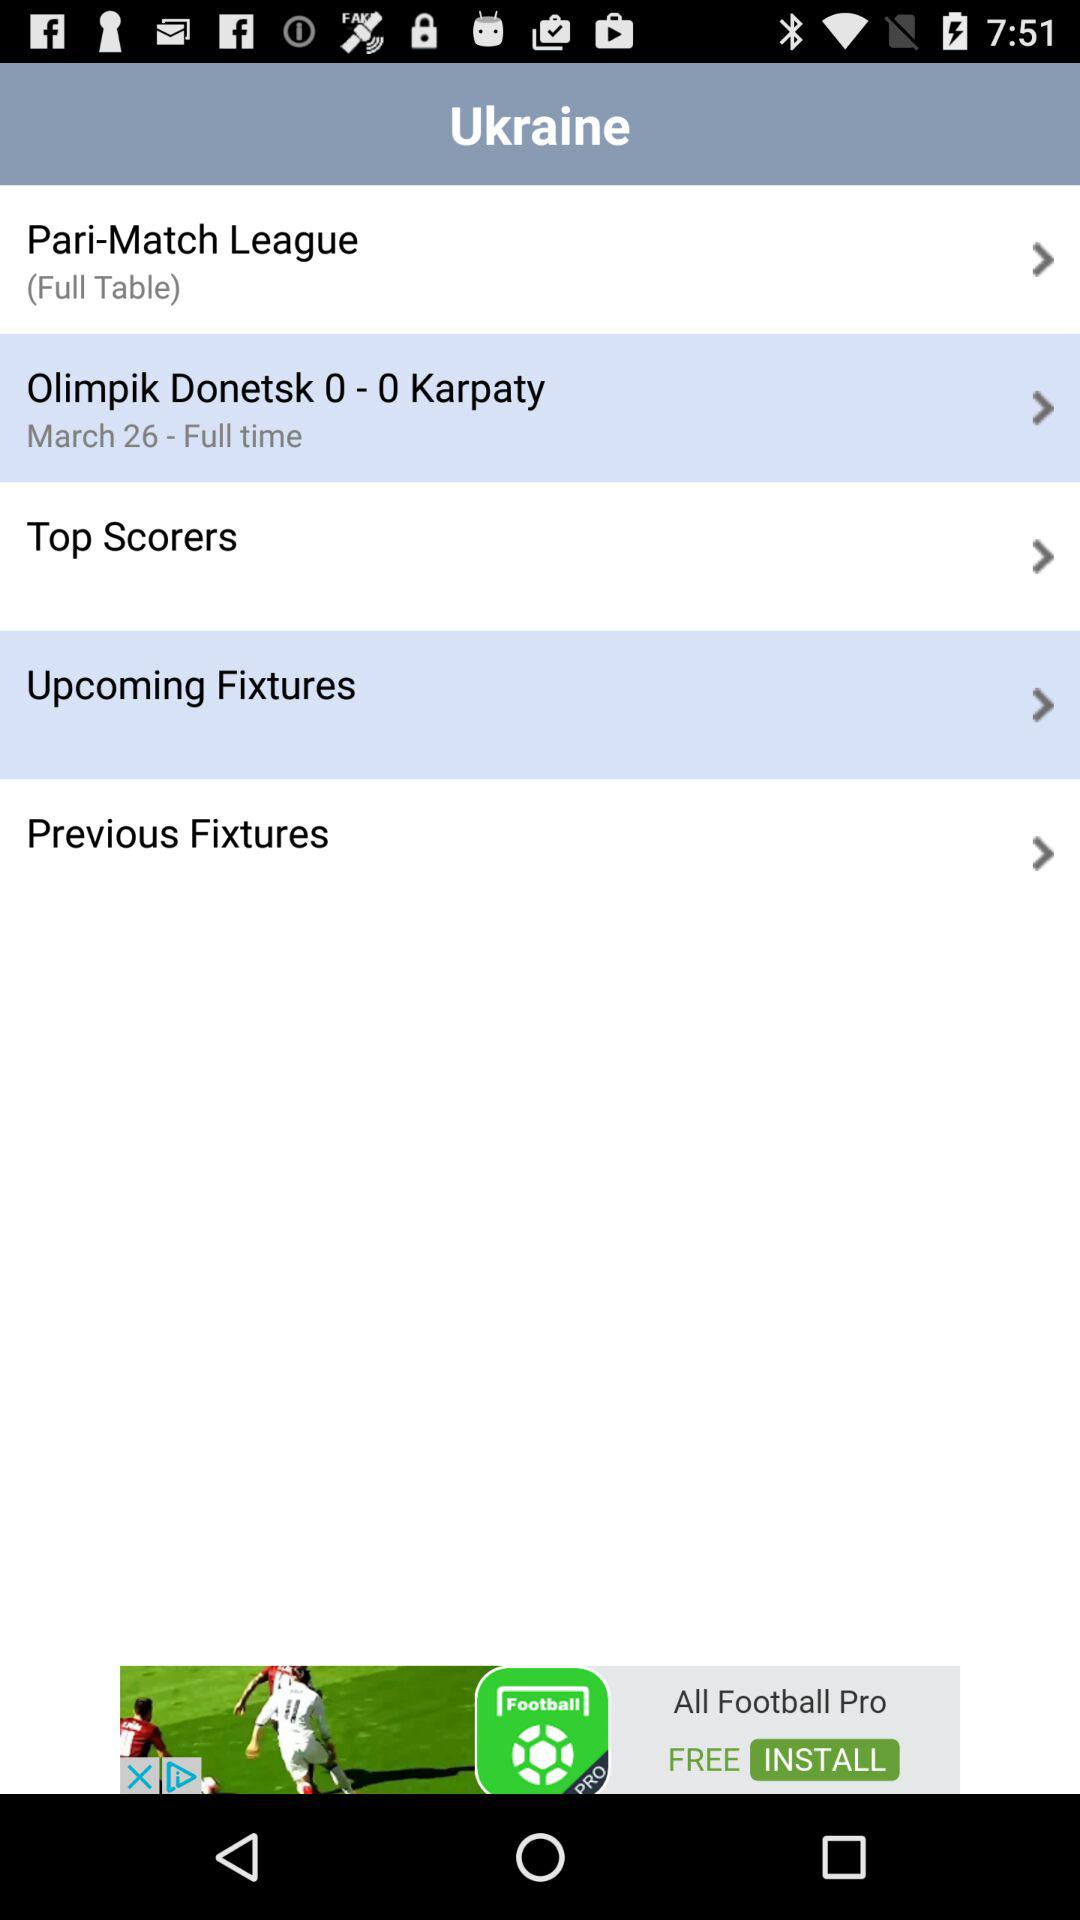How many items are under the Ukraine category?
Answer the question using a single word or phrase. 5 